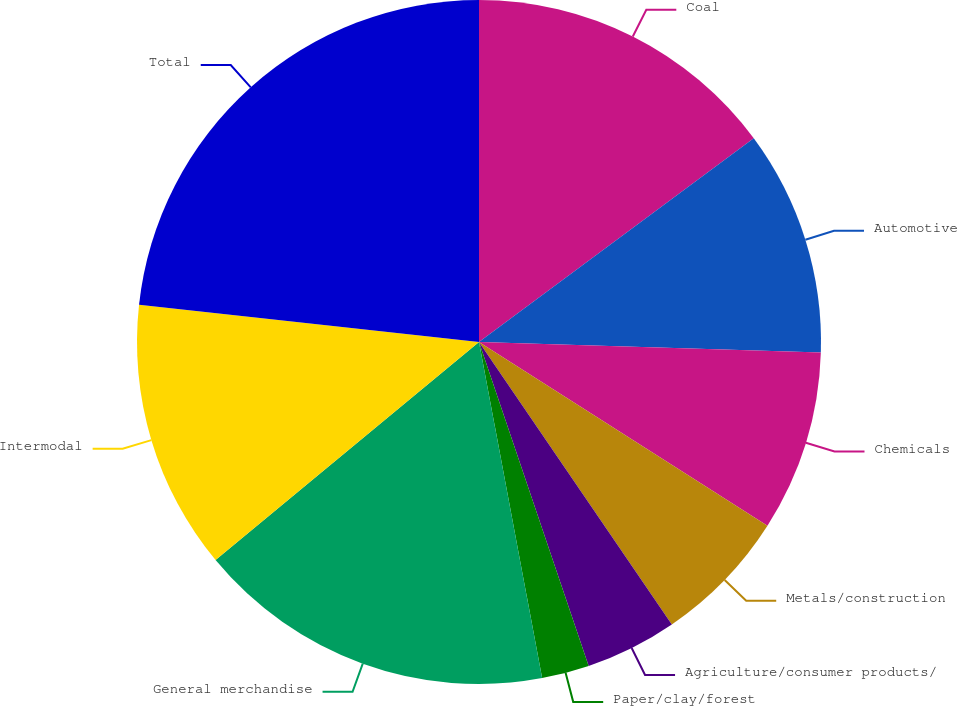Convert chart. <chart><loc_0><loc_0><loc_500><loc_500><pie_chart><fcel>Coal<fcel>Automotive<fcel>Chemicals<fcel>Metals/construction<fcel>Agriculture/consumer products/<fcel>Paper/clay/forest<fcel>General merchandise<fcel>Intermodal<fcel>Total<nl><fcel>14.85%<fcel>10.64%<fcel>8.54%<fcel>6.44%<fcel>4.34%<fcel>2.24%<fcel>16.95%<fcel>12.75%<fcel>23.26%<nl></chart> 